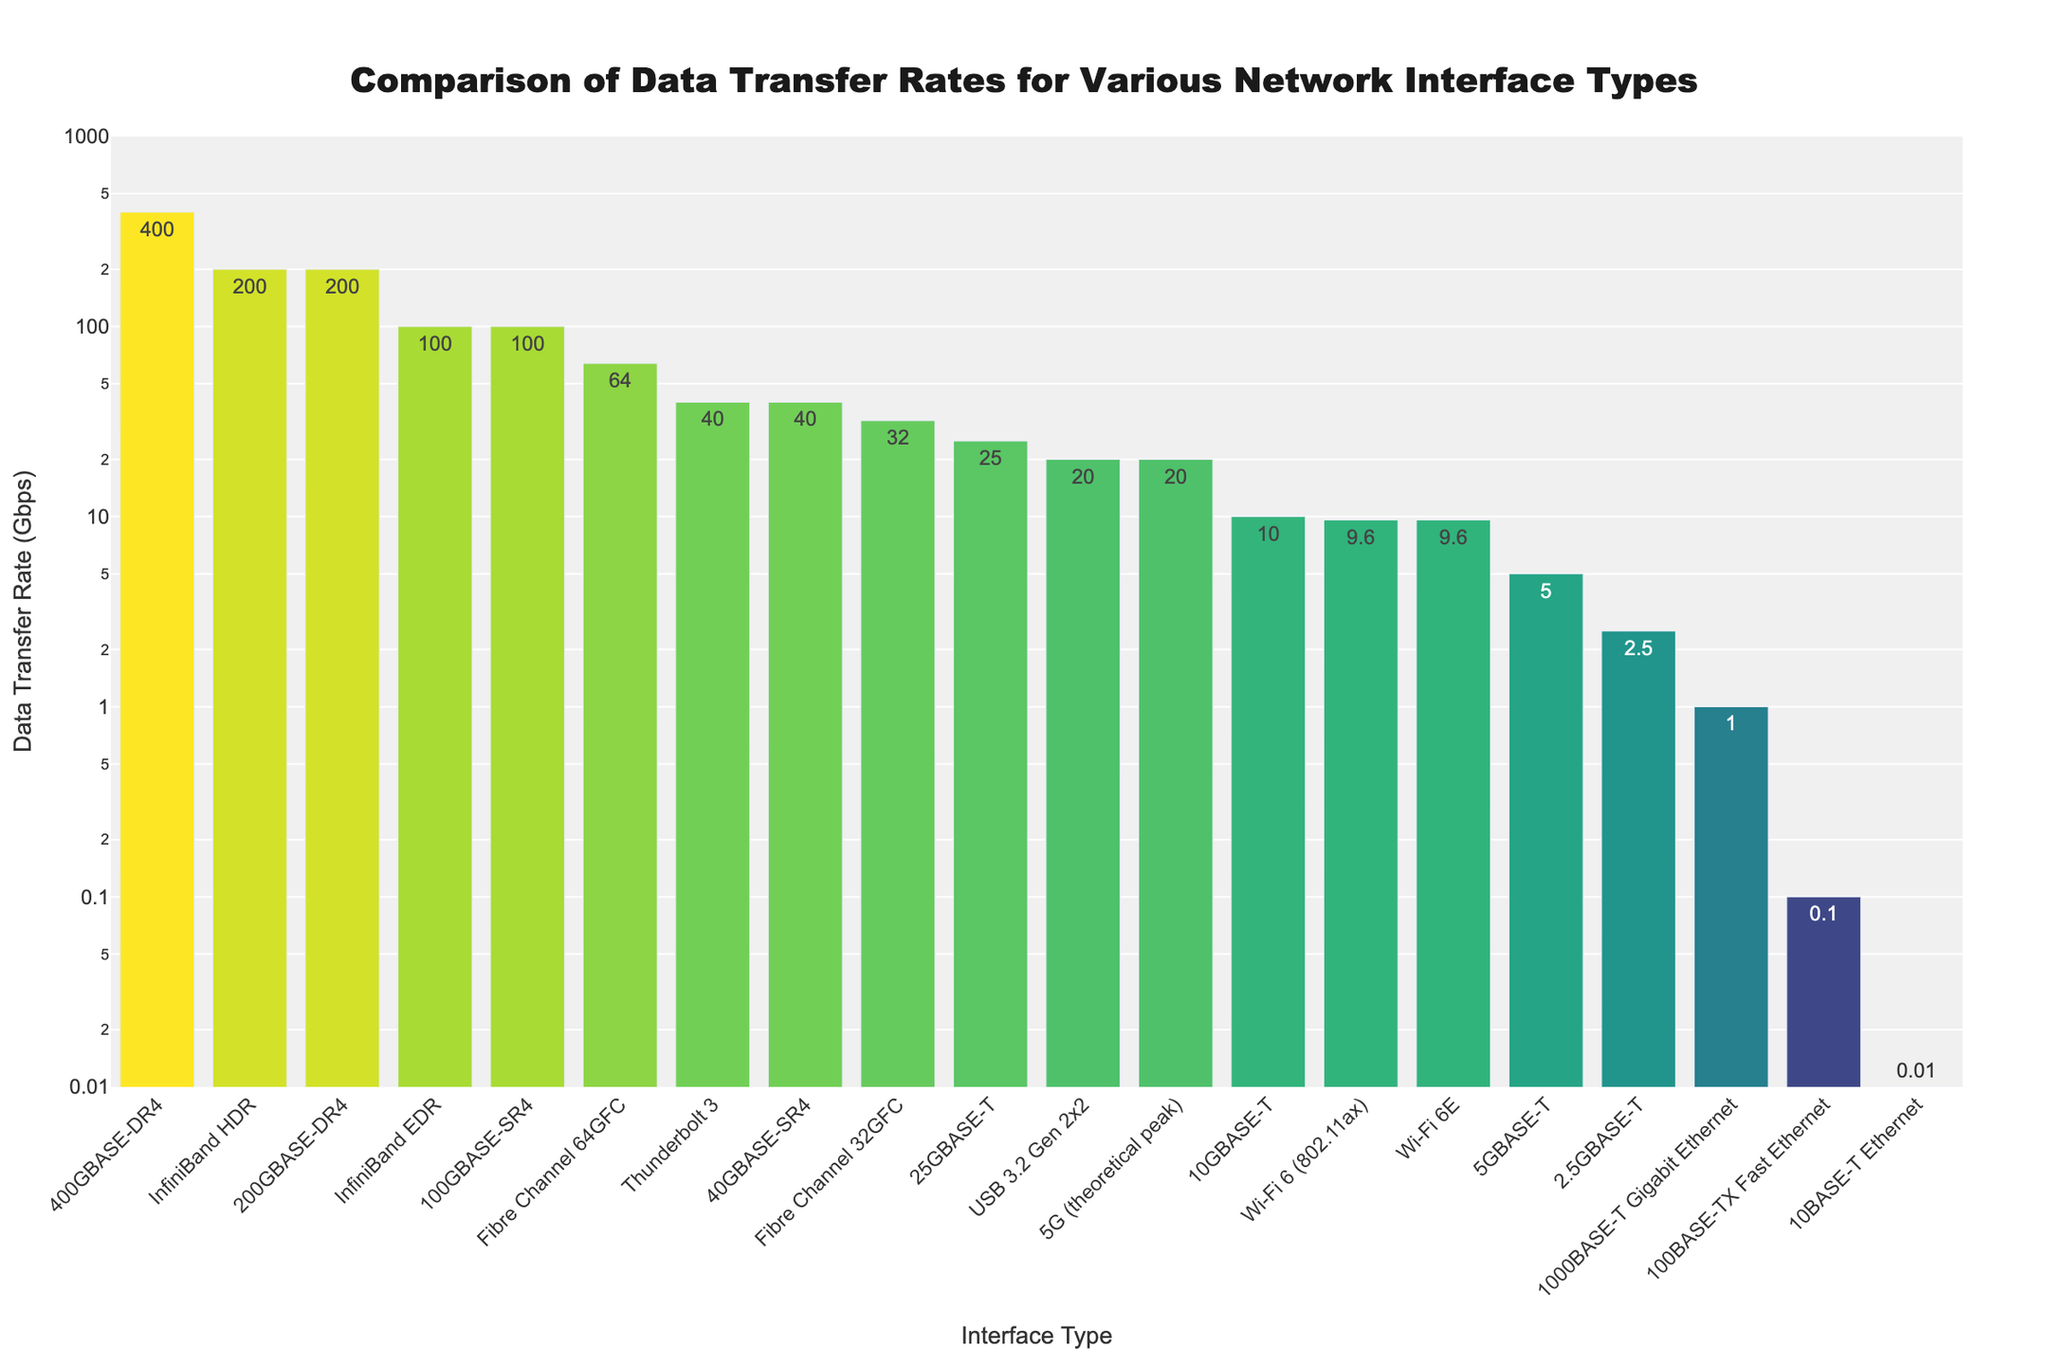What are the three network interfaces with the highest data transfer rates? By looking at the height of the bars, we see that the tallest bars indicating the highest data transfer rates correspond to 200GBASE-DR4, 400GBASE-DR4, and 100GBASE-SR4.
Answer: 400GBASE-DR4, 200GBASE-DR4, 100GBASE-SR4 Which interface type has a data transfer rate of exactly 20 Gbps? By checking the values shown on the bars, USB 3.2 Gen 2x2 and 5G (theoretical peak) both have data transfer rates of 20 Gbps.
Answer: USB 3.2 Gen 2x2, 5G (theoretical peak) What is the combined data transfer rate of Thunderbolt 3 and Wi-Fi 6 (802.11ax)? Thunderbolt 3 has a rate of 40 Gbps and Wi-Fi 6 (802.11ax) has a rate of 9.6 Gbps. Adding these together gives 40 + 9.6 = 49.6 Gbps.
Answer: 49.6 Gbps Which interface type has a higher data transfer rate: 1000BASE-T Gigabit Ethernet or Fibre Channel 32GFC? Comparing the heights and values of the bars, Fibre Channel 32GFC (32 Gbps) is higher than 1000BASE-T Gigabit Ethernet (1 Gbps).
Answer: Fibre Channel 32GFC How many interface types have a data transfer rate above 100 Gbps? By counting the bars with values greater than 100 Gbps, we see there are three: 400GBASE-DR4, 200GBASE-DR4, and InfiniBand HDR.
Answer: Three What is the difference in data transfer rates between 25GBASE-T and 5GBASE-T? 25GBASE-T has a rate of 25 Gbps and 5GBASE-T has a rate of 5 Gbps. The difference is 25 - 5 = 20 Gbps.
Answer: 20 Gbps Which interface has the lowest data transfer rate and what is it? The shortest bar belongs to 10BASE-T Ethernet, with a data transfer rate of 0.01 Gbps.
Answer: 10BASE-T Ethernet, 0.01 Gbps How does the data transfer rate of Wi-Fi 6E compare to Wi-Fi 6 (802.11ax)? Both Wi-Fi 6E and Wi-Fi 6 (802.11ax) have data transfer rates of 9.6 Gbps, as indicated by their equal bar heights.
Answer: Equal at 9.6 Gbps 